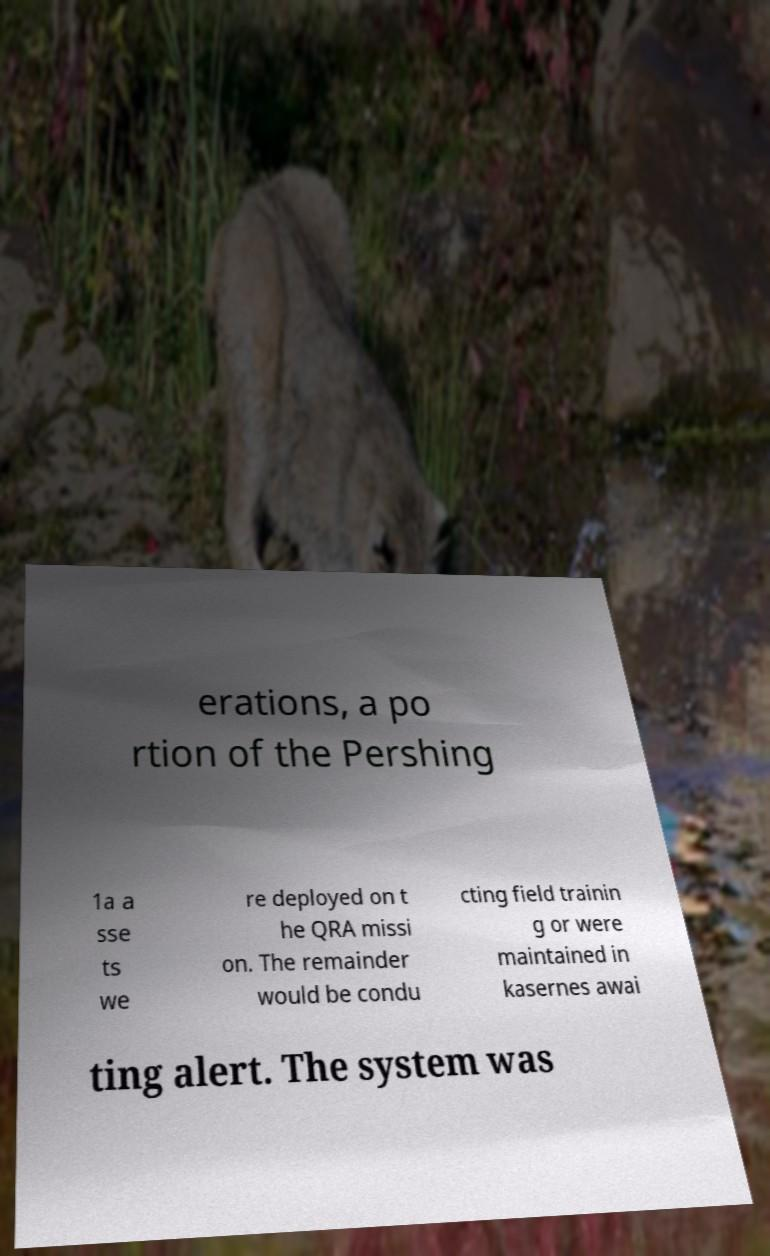I need the written content from this picture converted into text. Can you do that? erations, a po rtion of the Pershing 1a a sse ts we re deployed on t he QRA missi on. The remainder would be condu cting field trainin g or were maintained in kasernes awai ting alert. The system was 